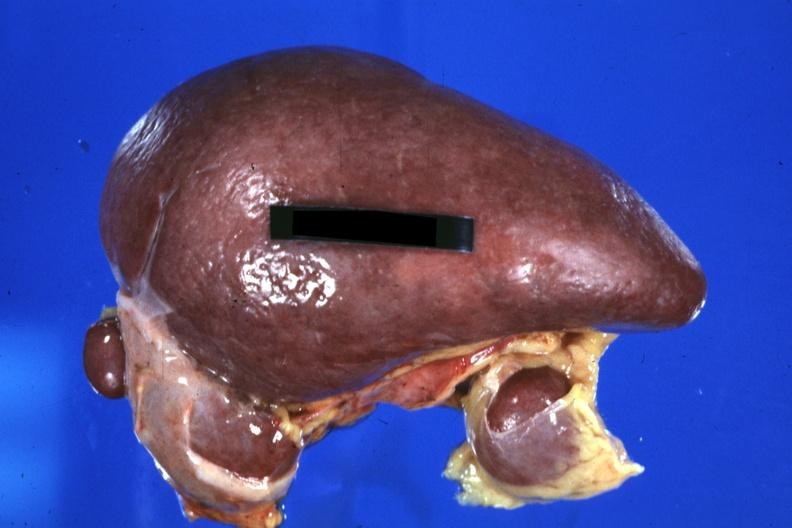what is present?
Answer the question using a single word or phrase. Hematologic 